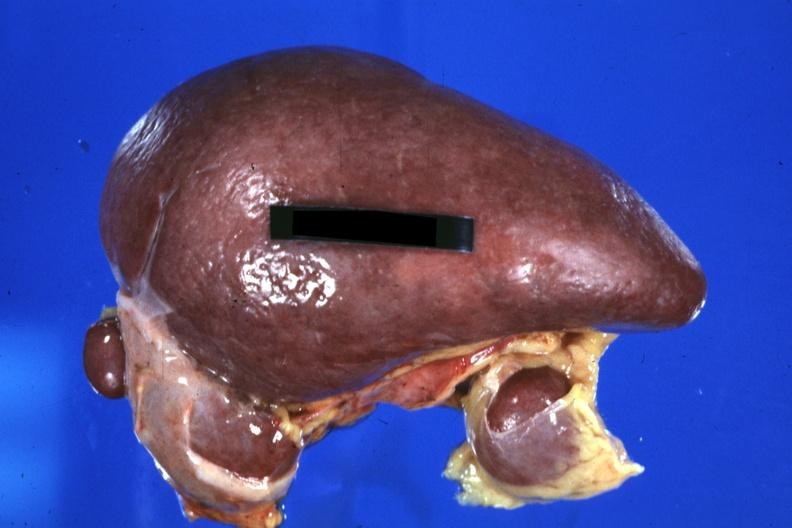what is present?
Answer the question using a single word or phrase. Hematologic 